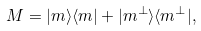<formula> <loc_0><loc_0><loc_500><loc_500>M = | m \rangle \langle m | + | m ^ { \perp } \rangle \langle m ^ { \perp } | ,</formula> 